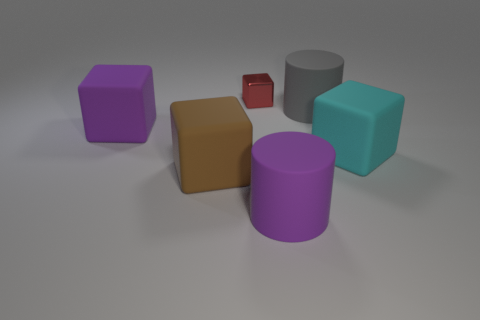Add 2 shiny objects. How many objects exist? 8 Subtract all cylinders. How many objects are left? 4 Add 4 big gray cylinders. How many big gray cylinders are left? 5 Add 5 large gray cylinders. How many large gray cylinders exist? 6 Subtract 1 purple cylinders. How many objects are left? 5 Subtract all blue rubber spheres. Subtract all brown rubber blocks. How many objects are left? 5 